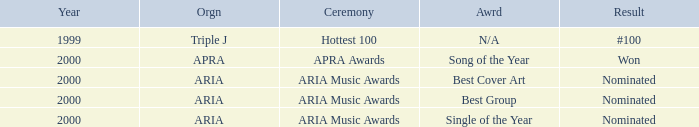Which award was nominated for in 2000? Best Cover Art, Best Group, Single of the Year. 